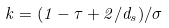<formula> <loc_0><loc_0><loc_500><loc_500>k = ( 1 - \tau + 2 / d _ { s } ) / \sigma</formula> 